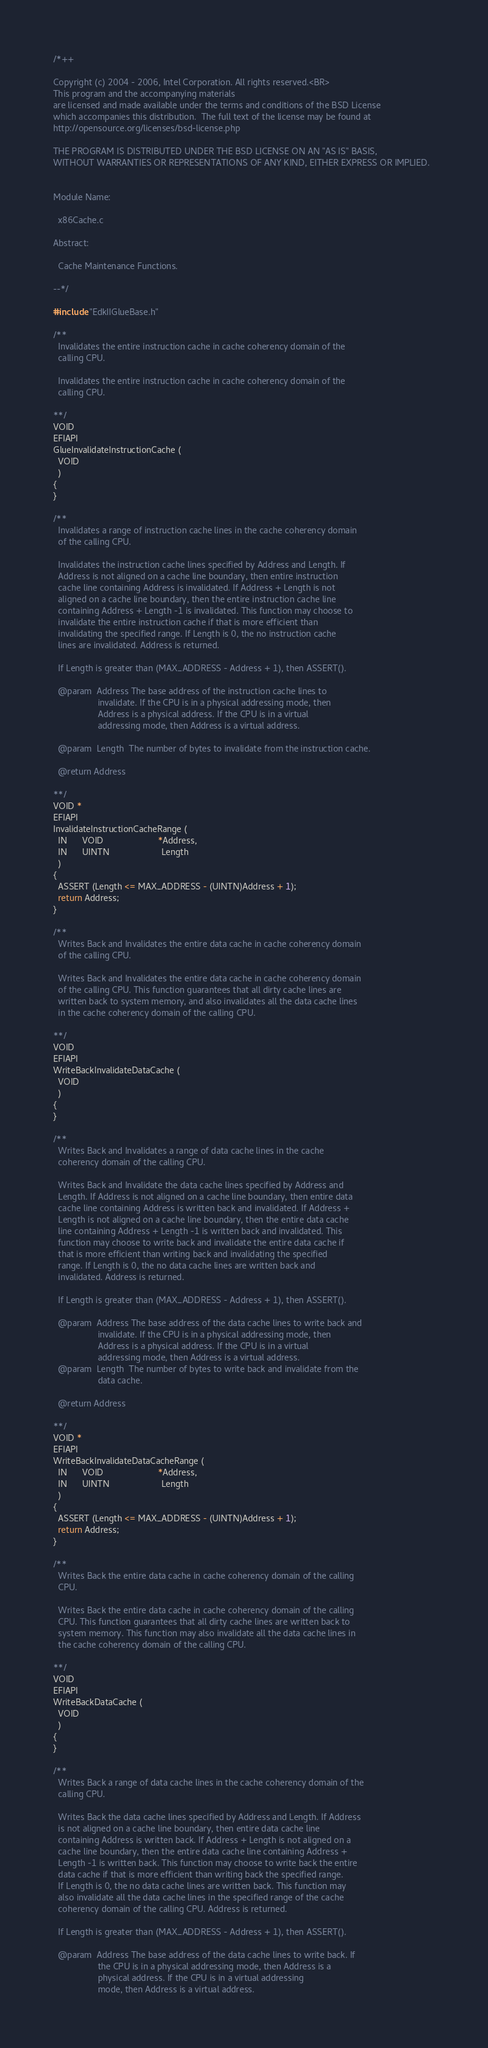Convert code to text. <code><loc_0><loc_0><loc_500><loc_500><_C_>/*++

Copyright (c) 2004 - 2006, Intel Corporation. All rights reserved.<BR>
This program and the accompanying materials                          
are licensed and made available under the terms and conditions of the BSD License         
which accompanies this distribution.  The full text of the license may be found at        
http://opensource.org/licenses/bsd-license.php                                            
                                                                                          
THE PROGRAM IS DISTRIBUTED UNDER THE BSD LICENSE ON AN "AS IS" BASIS,                     
WITHOUT WARRANTIES OR REPRESENTATIONS OF ANY KIND, EITHER EXPRESS OR IMPLIED.  


Module Name:

  x86Cache.c
  
Abstract: 

  Cache Maintenance Functions.

--*/

#include "EdkIIGlueBase.h"

/**
  Invalidates the entire instruction cache in cache coherency domain of the
  calling CPU.

  Invalidates the entire instruction cache in cache coherency domain of the
  calling CPU.

**/
VOID
EFIAPI
GlueInvalidateInstructionCache (
  VOID
  )
{
}

/**
  Invalidates a range of instruction cache lines in the cache coherency domain
  of the calling CPU.

  Invalidates the instruction cache lines specified by Address and Length. If
  Address is not aligned on a cache line boundary, then entire instruction
  cache line containing Address is invalidated. If Address + Length is not
  aligned on a cache line boundary, then the entire instruction cache line
  containing Address + Length -1 is invalidated. This function may choose to
  invalidate the entire instruction cache if that is more efficient than
  invalidating the specified range. If Length is 0, the no instruction cache
  lines are invalidated. Address is returned.

  If Length is greater than (MAX_ADDRESS - Address + 1), then ASSERT().

  @param  Address The base address of the instruction cache lines to
                  invalidate. If the CPU is in a physical addressing mode, then
                  Address is a physical address. If the CPU is in a virtual
                  addressing mode, then Address is a virtual address.

  @param  Length  The number of bytes to invalidate from the instruction cache.

  @return Address

**/
VOID *
EFIAPI
InvalidateInstructionCacheRange (
  IN      VOID                      *Address,
  IN      UINTN                     Length
  )
{
  ASSERT (Length <= MAX_ADDRESS - (UINTN)Address + 1);
  return Address;
}

/**
  Writes Back and Invalidates the entire data cache in cache coherency domain
  of the calling CPU.

  Writes Back and Invalidates the entire data cache in cache coherency domain
  of the calling CPU. This function guarantees that all dirty cache lines are
  written back to system memory, and also invalidates all the data cache lines
  in the cache coherency domain of the calling CPU.

**/
VOID
EFIAPI
WriteBackInvalidateDataCache (
  VOID
  )
{
}

/**
  Writes Back and Invalidates a range of data cache lines in the cache
  coherency domain of the calling CPU.

  Writes Back and Invalidate the data cache lines specified by Address and
  Length. If Address is not aligned on a cache line boundary, then entire data
  cache line containing Address is written back and invalidated. If Address +
  Length is not aligned on a cache line boundary, then the entire data cache
  line containing Address + Length -1 is written back and invalidated. This
  function may choose to write back and invalidate the entire data cache if
  that is more efficient than writing back and invalidating the specified
  range. If Length is 0, the no data cache lines are written back and
  invalidated. Address is returned.

  If Length is greater than (MAX_ADDRESS - Address + 1), then ASSERT().

  @param  Address The base address of the data cache lines to write back and
                  invalidate. If the CPU is in a physical addressing mode, then
                  Address is a physical address. If the CPU is in a virtual
                  addressing mode, then Address is a virtual address.
  @param  Length  The number of bytes to write back and invalidate from the
                  data cache.

  @return Address

**/
VOID *
EFIAPI
WriteBackInvalidateDataCacheRange (
  IN      VOID                      *Address,
  IN      UINTN                     Length
  )
{
  ASSERT (Length <= MAX_ADDRESS - (UINTN)Address + 1);
  return Address;
}

/**
  Writes Back the entire data cache in cache coherency domain of the calling
  CPU.

  Writes Back the entire data cache in cache coherency domain of the calling
  CPU. This function guarantees that all dirty cache lines are written back to
  system memory. This function may also invalidate all the data cache lines in
  the cache coherency domain of the calling CPU.

**/
VOID
EFIAPI
WriteBackDataCache (
  VOID
  )
{
}

/**
  Writes Back a range of data cache lines in the cache coherency domain of the
  calling CPU.

  Writes Back the data cache lines specified by Address and Length. If Address
  is not aligned on a cache line boundary, then entire data cache line
  containing Address is written back. If Address + Length is not aligned on a
  cache line boundary, then the entire data cache line containing Address +
  Length -1 is written back. This function may choose to write back the entire
  data cache if that is more efficient than writing back the specified range.
  If Length is 0, the no data cache lines are written back. This function may
  also invalidate all the data cache lines in the specified range of the cache
  coherency domain of the calling CPU. Address is returned.

  If Length is greater than (MAX_ADDRESS - Address + 1), then ASSERT().

  @param  Address The base address of the data cache lines to write back. If
                  the CPU is in a physical addressing mode, then Address is a
                  physical address. If the CPU is in a virtual addressing
                  mode, then Address is a virtual address.</code> 